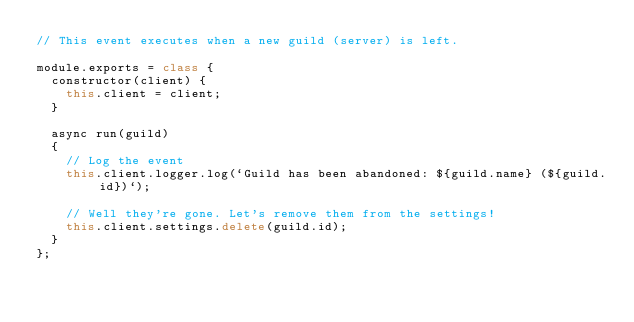Convert code to text. <code><loc_0><loc_0><loc_500><loc_500><_JavaScript_>// This event executes when a new guild (server) is left.

module.exports = class {
  constructor(client) {
    this.client = client;
  }

  async run(guild) 
  {
    // Log the event
    this.client.logger.log(`Guild has been abandoned: ${guild.name} (${guild.id})`);

    // Well they're gone. Let's remove them from the settings!
    this.client.settings.delete(guild.id);
  }
};
</code> 